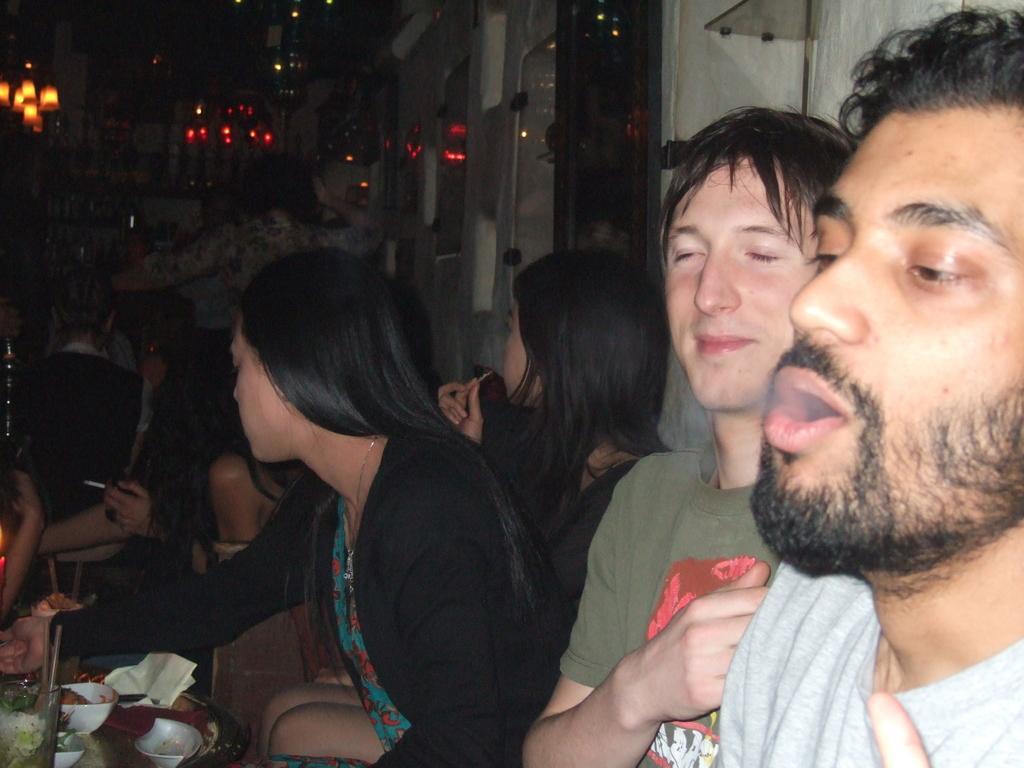Please provide a concise description of this image. In this image I can see group of people sitting. In front the person is wearing white color shirt and I can also see few food items in the bowls. In the background I can see few lights. 